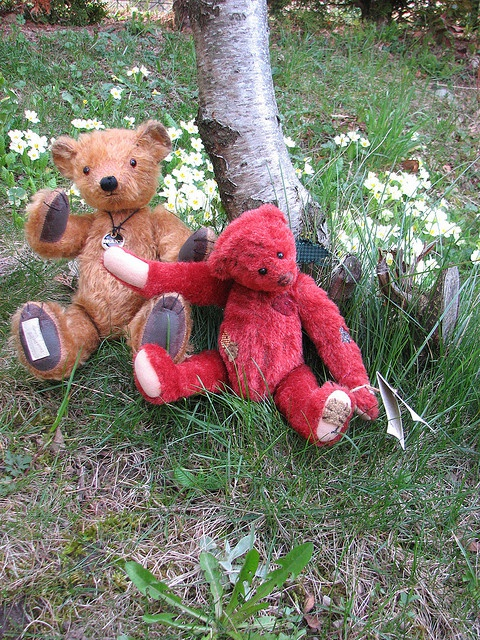Describe the objects in this image and their specific colors. I can see teddy bear in turquoise, brown, salmon, and maroon tones and teddy bear in turquoise, brown, lightpink, gray, and salmon tones in this image. 